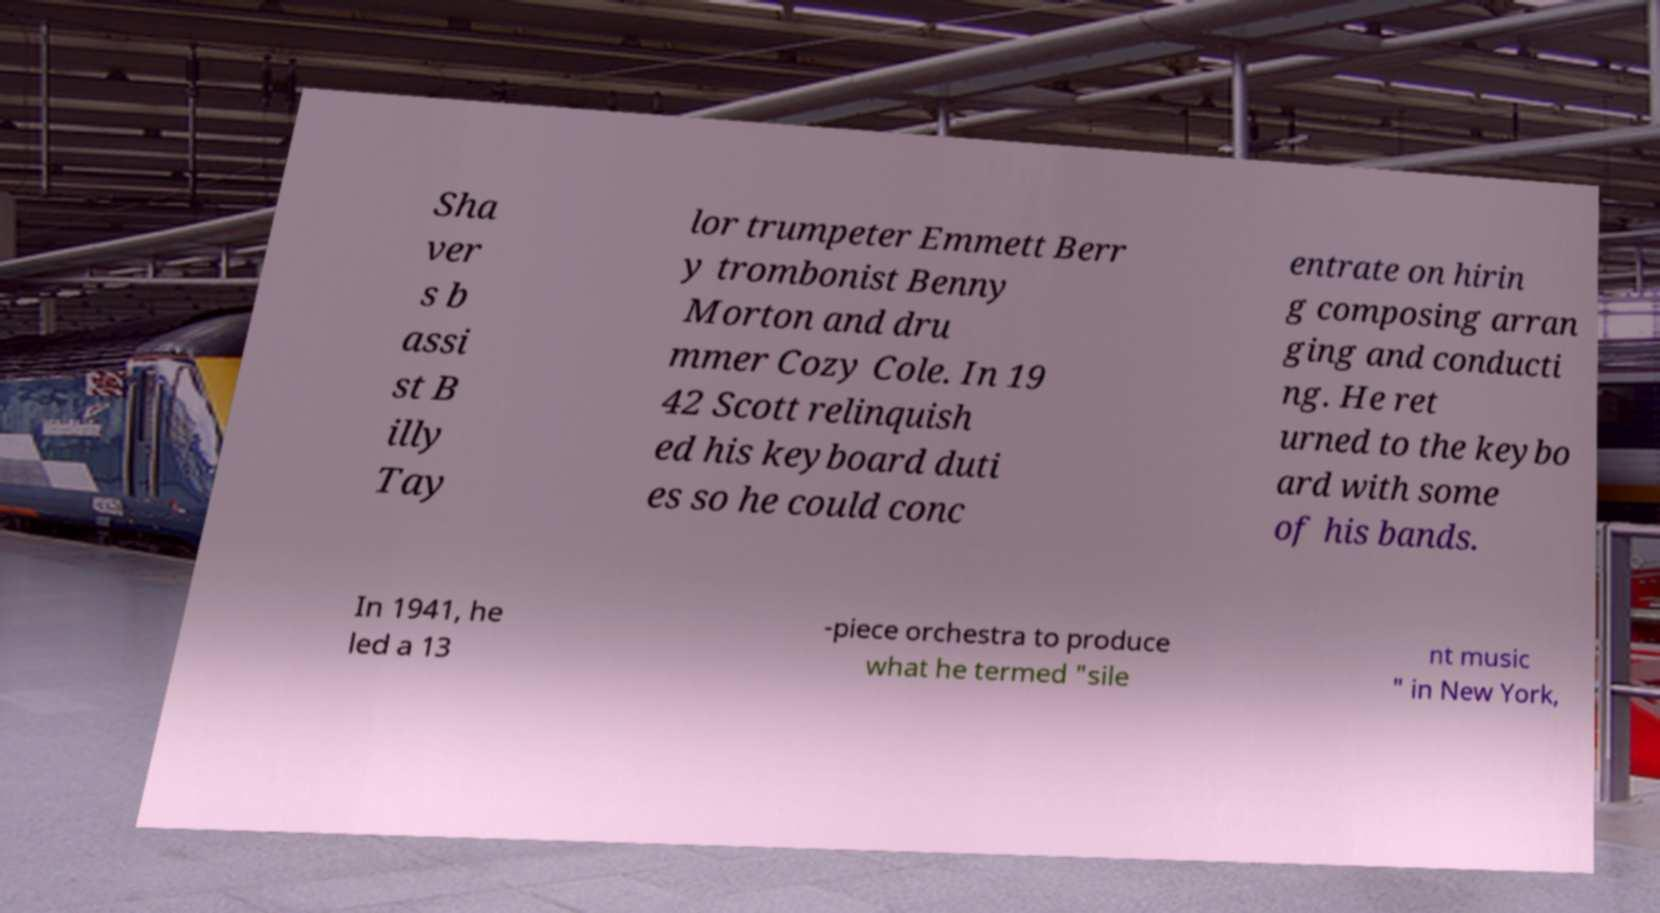Could you assist in decoding the text presented in this image and type it out clearly? Sha ver s b assi st B illy Tay lor trumpeter Emmett Berr y trombonist Benny Morton and dru mmer Cozy Cole. In 19 42 Scott relinquish ed his keyboard duti es so he could conc entrate on hirin g composing arran ging and conducti ng. He ret urned to the keybo ard with some of his bands. In 1941, he led a 13 -piece orchestra to produce what he termed "sile nt music " in New York, 